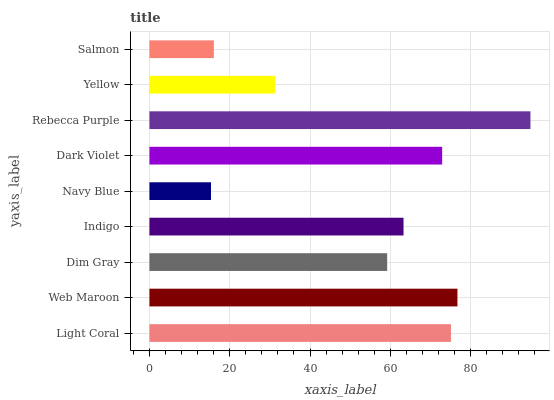Is Navy Blue the minimum?
Answer yes or no. Yes. Is Rebecca Purple the maximum?
Answer yes or no. Yes. Is Web Maroon the minimum?
Answer yes or no. No. Is Web Maroon the maximum?
Answer yes or no. No. Is Web Maroon greater than Light Coral?
Answer yes or no. Yes. Is Light Coral less than Web Maroon?
Answer yes or no. Yes. Is Light Coral greater than Web Maroon?
Answer yes or no. No. Is Web Maroon less than Light Coral?
Answer yes or no. No. Is Indigo the high median?
Answer yes or no. Yes. Is Indigo the low median?
Answer yes or no. Yes. Is Web Maroon the high median?
Answer yes or no. No. Is Rebecca Purple the low median?
Answer yes or no. No. 